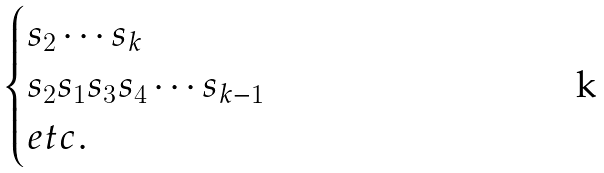<formula> <loc_0><loc_0><loc_500><loc_500>\begin{cases} s _ { 2 } \cdots s _ { k } \\ s _ { 2 } s _ { 1 } s _ { 3 } s _ { 4 } \cdots s _ { k - 1 } \\ e t c . \end{cases}</formula> 